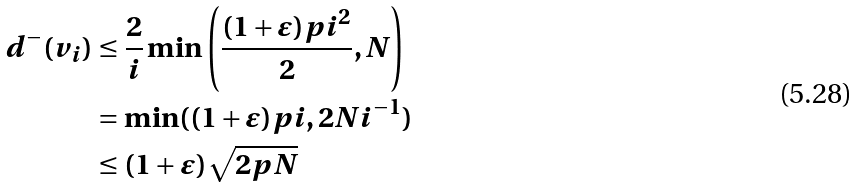<formula> <loc_0><loc_0><loc_500><loc_500>d ^ { - } ( v _ { i } ) & \leq \frac { 2 } { i } \min \left ( \frac { ( 1 + \varepsilon ) p i ^ { 2 } } { 2 } , N \right ) \\ & = \min ( ( 1 + \varepsilon ) p i , 2 N i ^ { - 1 } ) \\ & \leq ( 1 + \varepsilon ) \sqrt { 2 p N }</formula> 